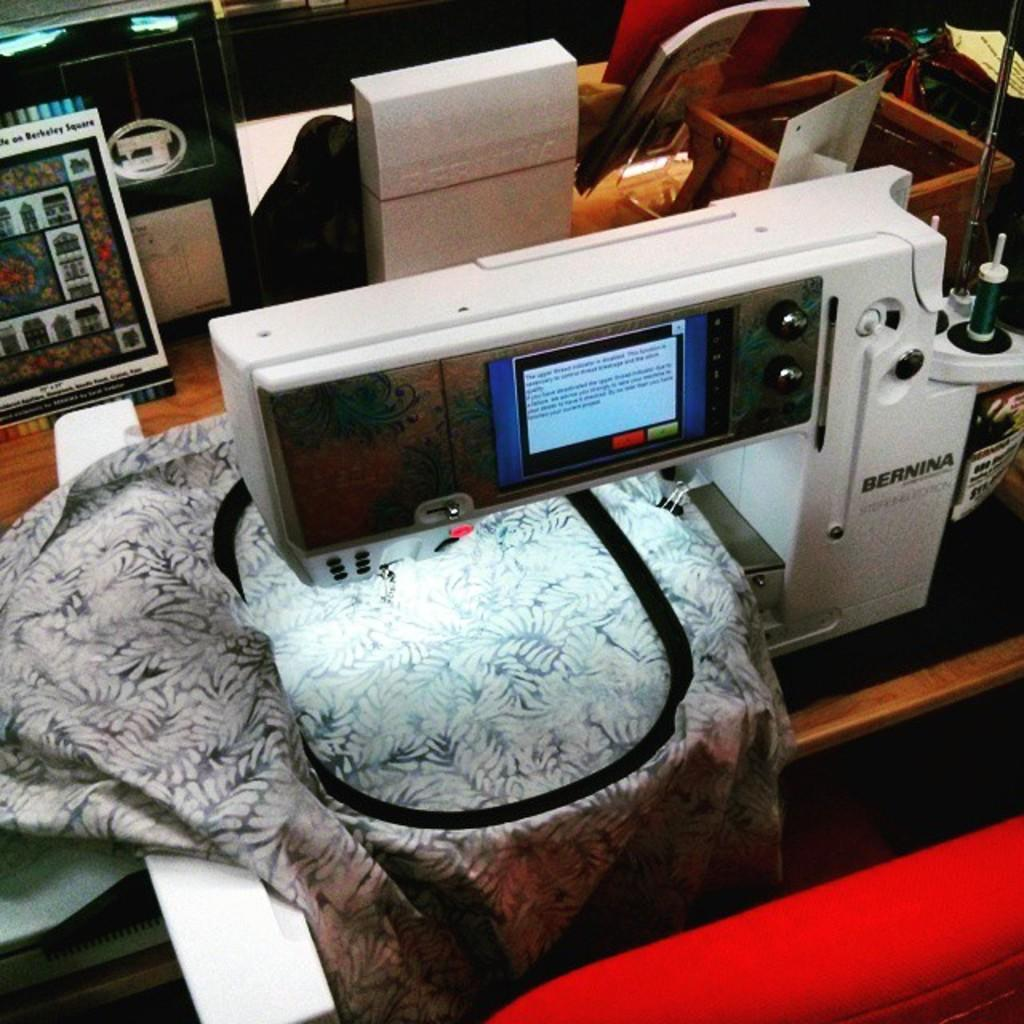What type of objects can be seen on the table in the image? There are electronic gadgets on the table in the image. What type of material is used for the cloths in the image? The cloths in the image are made of fabric. What are the boards used for in the image? The boards in the image are likely used for displaying or organizing objects. How many objects can be seen in the image? There are many objects visible in the image. What type of authority is depicted on the wall in the image? There is no wall or authority figure present in the image. What type of town is shown in the image? There is no town visible in the image; it features electronic gadgets, cloths, and boards on a table. 